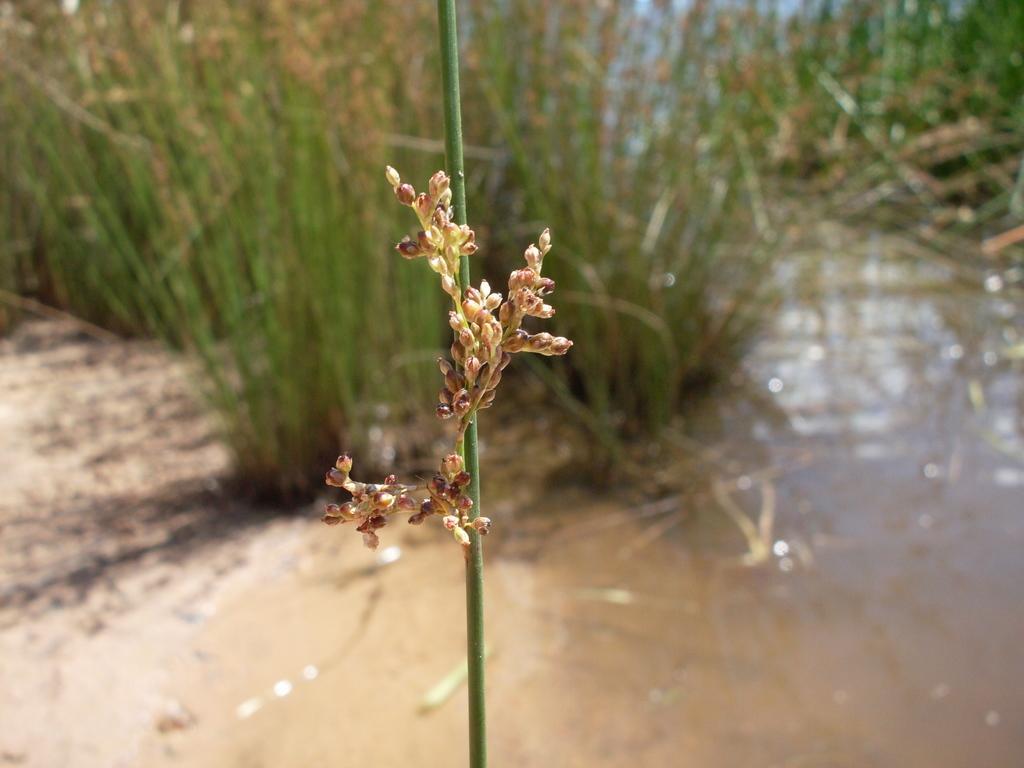Could you give a brief overview of what you see in this image? In the picture there are grass plants present, there is water. 